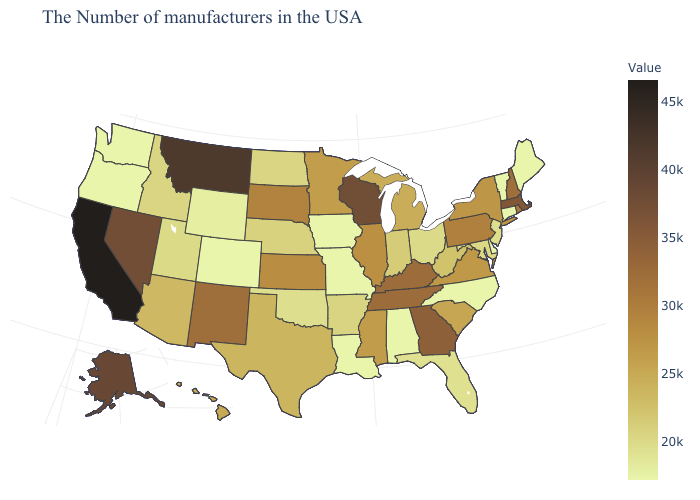Among the states that border Massachusetts , which have the highest value?
Write a very short answer. New Hampshire. Does California have the highest value in the West?
Keep it brief. Yes. Does California have the highest value in the USA?
Short answer required. Yes. Is the legend a continuous bar?
Answer briefly. Yes. Which states have the lowest value in the Northeast?
Be succinct. Maine, Vermont, Connecticut. Does Ohio have a lower value than South Dakota?
Concise answer only. Yes. Which states have the lowest value in the USA?
Write a very short answer. Maine, Vermont, Connecticut, Delaware, North Carolina, Alabama, Louisiana, Missouri, Iowa, Colorado, Washington, Oregon. 